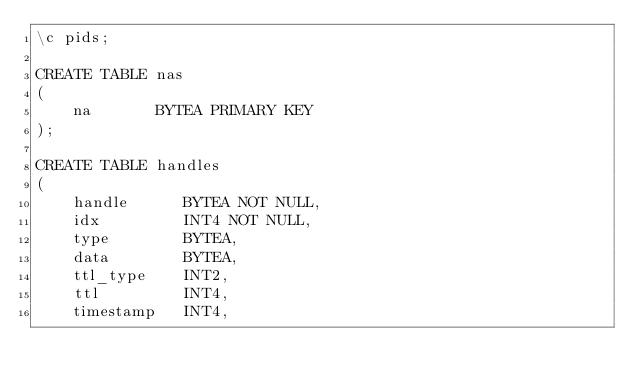Convert code to text. <code><loc_0><loc_0><loc_500><loc_500><_SQL_>\c pids;

CREATE TABLE nas
(
    na       BYTEA PRIMARY KEY
);

CREATE TABLE handles
(
    handle      BYTEA NOT NULL,
    idx         INT4 NOT NULL,
    type        BYTEA,
    data        BYTEA,
    ttl_type    INT2,
    ttl         INT4,
    timestamp   INT4,</code> 